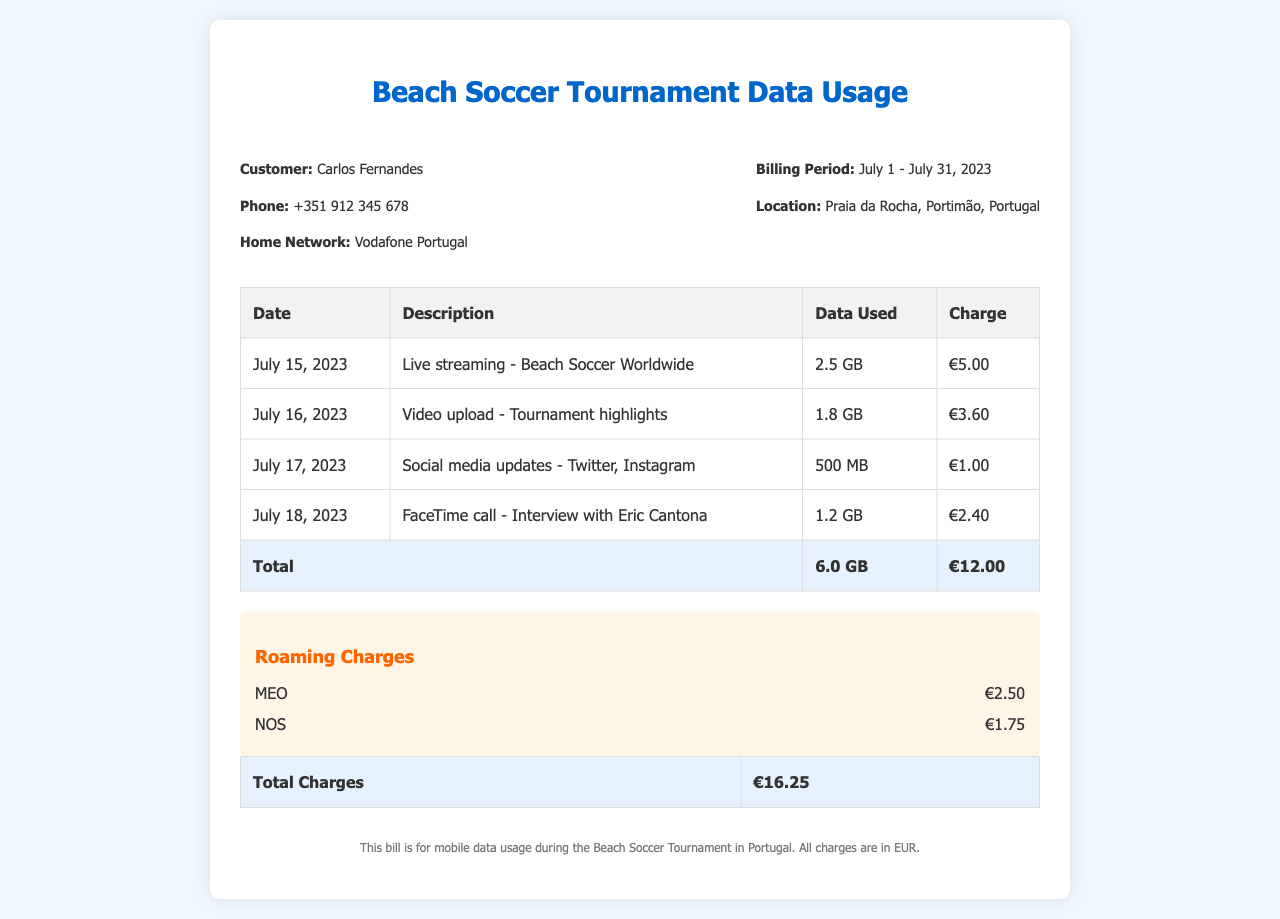What is the customer's name? The document specifically lists the customer's name as Carlos Fernandes.
Answer: Carlos Fernandes What is the total data used? The total data used is given in the summary row of the data usage table. It sums all individual data usages together.
Answer: 6.0 GB How much was charged for the FaceTime call? The specific charge for the FaceTime call is detailed in the table, indicating its individual cost.
Answer: €2.40 What are the roaming charges from MEO? The document lists the roaming charges separately, specifically for MEO.
Answer: €2.50 What date was the video upload made? The date for the video upload is explicitly stated in the table under the relevant description.
Answer: July 16, 2023 What is the total amount charged after roaming? The total charges, including roaming, are stated in the last table row, indicating all charges summed up.
Answer: €16.25 What was the purpose of the biggest data usage entry? The largest data usage entry describes a specific activity that required extensive data during the tournament.
Answer: Live streaming How much was charged for social media updates? The specific charge for social media updates can be found directly in the detailed usage table provided.
Answer: €1.00 What location is specified for the billing? The document clearly states where the tournament took place, reflecting its importance to the context.
Answer: Praia da Rocha, Portimão, Portugal 